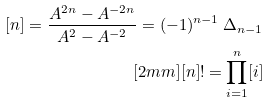<formula> <loc_0><loc_0><loc_500><loc_500>[ n ] = \frac { A ^ { 2 n } - A ^ { - 2 n } } { A ^ { 2 } - A ^ { - 2 } } = ( - 1 ) ^ { n - 1 } \, \Delta _ { n - 1 } \\ [ 2 m m ] [ n ] ! = \prod _ { i = 1 } ^ { n } [ i ]</formula> 